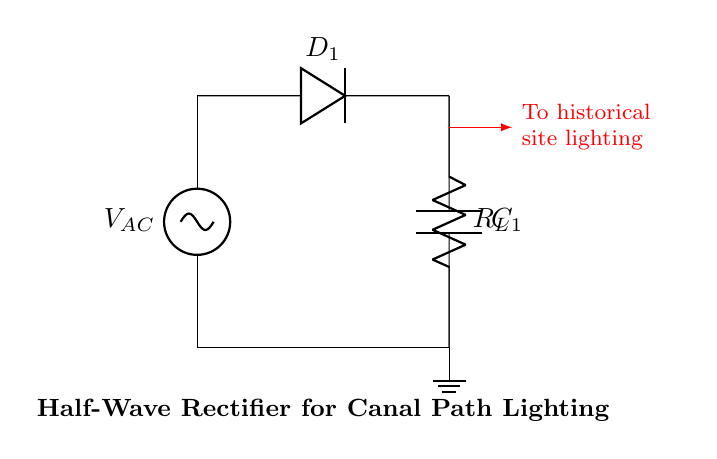What is the type of source used in this circuit? The circuit uses an alternating current source, indicated by the symbol for voltage source labeled V_AC. This is the primary input needed for a half-wave rectifier, which allows current to flow in only one direction.
Answer: Alternating current What component allows current to flow in only one direction? The diode, labeled D_1 in the diagram, permits current to flow only from its anode to cathode, effectively blocking any reverse current. This is essential for the rectification process in a half-wave rectifier.
Answer: Diode How many capacitors are present in this circuit? There is one capacitor in the circuit, labeled C_1. Capacitors are included in rectifier circuits to smooth out the output voltage by storing charge and releasing it when necessary, minimizing fluctuations.
Answer: One What is the role of the resistor in the circuit? The resistor, labeled R_L, serves as a load in the circuit, converting electrical energy into light or heat. It is vital for determining how much current flows through the circuit and therefore affects the overall output.
Answer: Load What type of circuit is represented here? This circuit is a half-wave rectifier, as evidenced by the configuration of the diode allowing only half of the AC signal to pass, which is a characteristic of half-wave rectification; it’s specifically designed to convert AC to DC for practical use.
Answer: Half-wave rectifier What is the output voltage connected to? The output voltage from the circuit is connected to historical site lighting, as indicated by the arrow leading out from the circuit labeled "To historical site lighting." This shows the practical application of the rectifier’s output.
Answer: Historical site lighting 